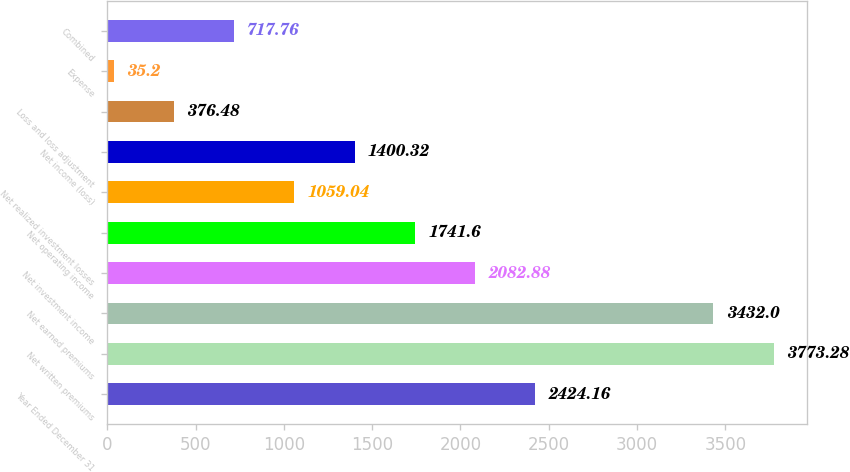Convert chart to OTSL. <chart><loc_0><loc_0><loc_500><loc_500><bar_chart><fcel>Year Ended December 31<fcel>Net written premiums<fcel>Net earned premiums<fcel>Net investment income<fcel>Net operating income<fcel>Net realized investment losses<fcel>Net income (loss)<fcel>Loss and loss adjustment<fcel>Expense<fcel>Combined<nl><fcel>2424.16<fcel>3773.28<fcel>3432<fcel>2082.88<fcel>1741.6<fcel>1059.04<fcel>1400.32<fcel>376.48<fcel>35.2<fcel>717.76<nl></chart> 